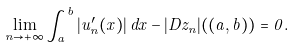Convert formula to latex. <formula><loc_0><loc_0><loc_500><loc_500>\lim _ { n \to + \infty } \int _ { a } ^ { b } | u _ { n } ^ { \prime } ( x ) | \, d x - | D z _ { n } | ( ( a , b ) ) = 0 .</formula> 